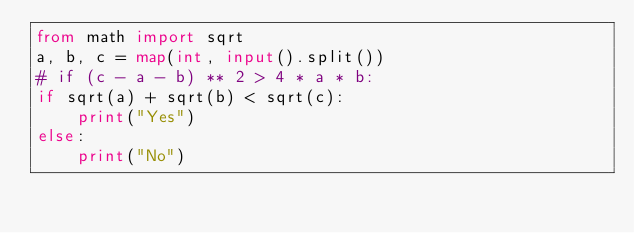<code> <loc_0><loc_0><loc_500><loc_500><_Python_>from math import sqrt
a, b, c = map(int, input().split())
# if (c - a - b) ** 2 > 4 * a * b:
if sqrt(a) + sqrt(b) < sqrt(c):
    print("Yes")
else:
    print("No")</code> 